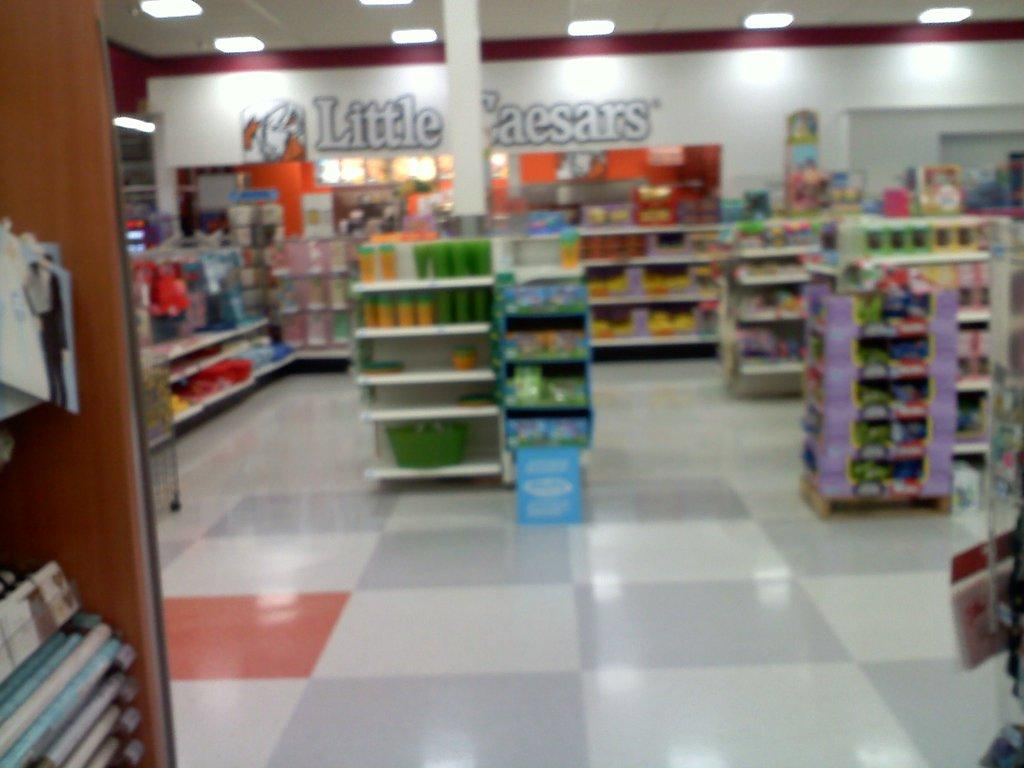Provide a one-sentence caption for the provided image. A gas station that has Little Caesars written on the back wall. 